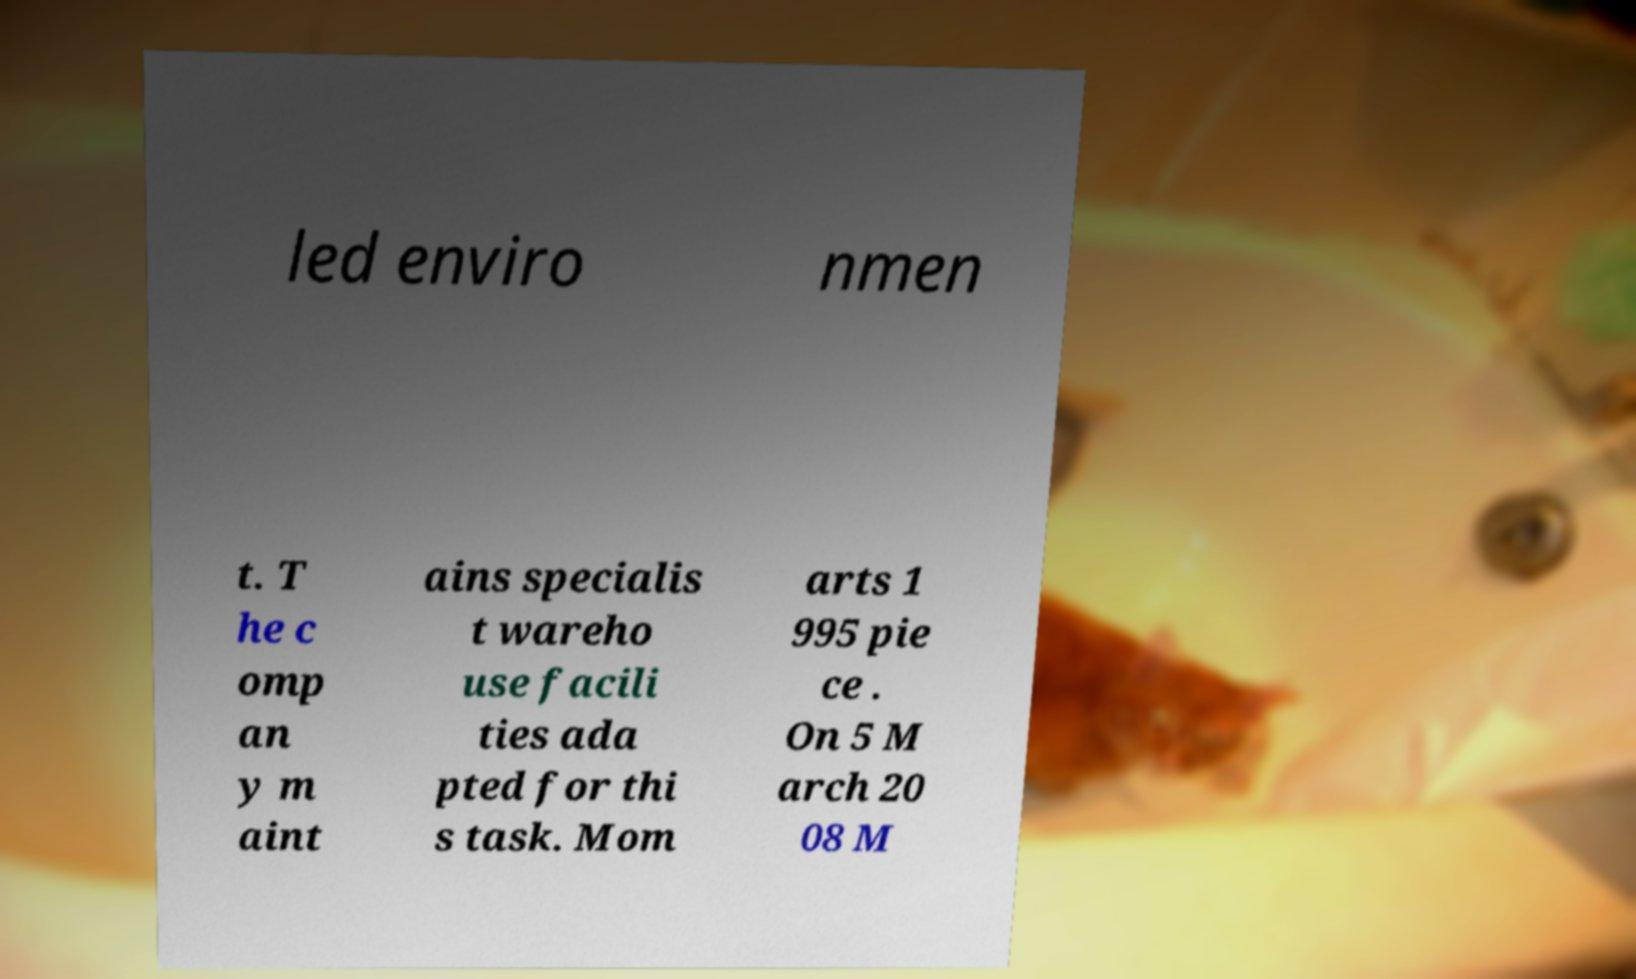Can you read and provide the text displayed in the image?This photo seems to have some interesting text. Can you extract and type it out for me? led enviro nmen t. T he c omp an y m aint ains specialis t wareho use facili ties ada pted for thi s task. Mom arts 1 995 pie ce . On 5 M arch 20 08 M 